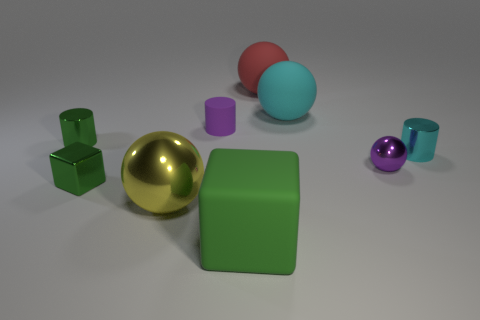Subtract 1 spheres. How many spheres are left? 3 Subtract all blocks. How many objects are left? 7 Subtract 0 blue cylinders. How many objects are left? 9 Subtract all purple cylinders. Subtract all small green shiny cylinders. How many objects are left? 7 Add 9 tiny rubber things. How many tiny rubber things are left? 10 Add 7 big yellow spheres. How many big yellow spheres exist? 8 